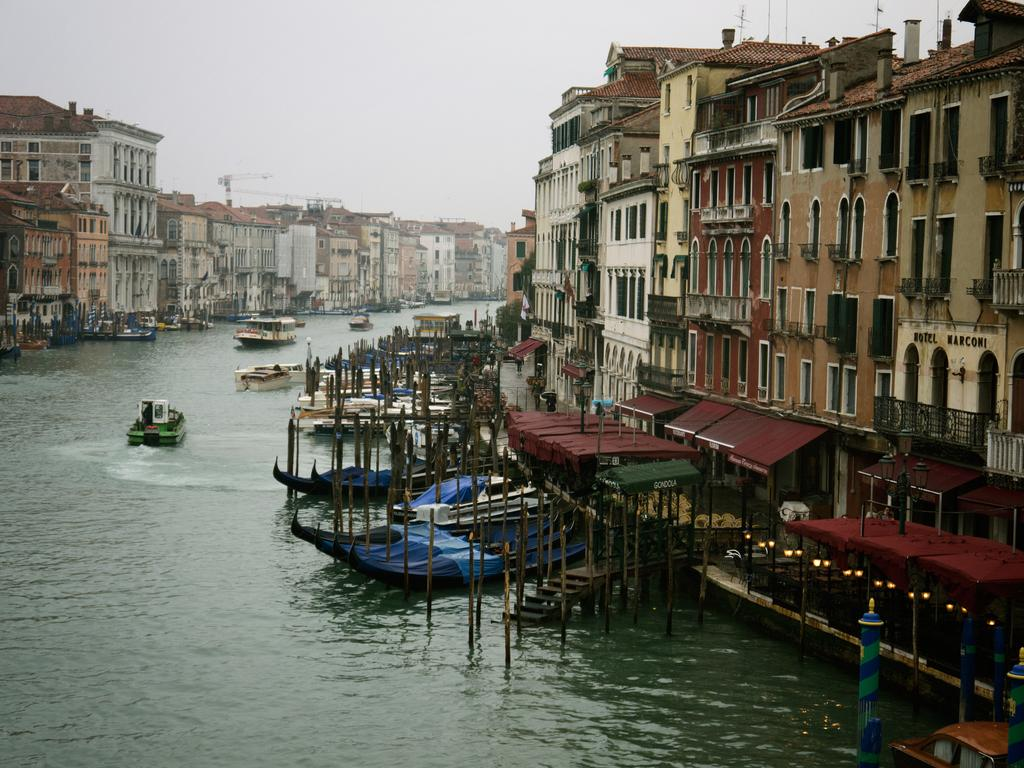What is the main feature in the center of the image? There is a canal in the center of the image. What is on the canal? There are boats on the canal. What can be seen in the background of the image? There are buildings and the sky visible in the background of the image. What type of credit card is being used by the person in the image? There is no person or credit card present in the image; it features a canal with boats and buildings in the background. 